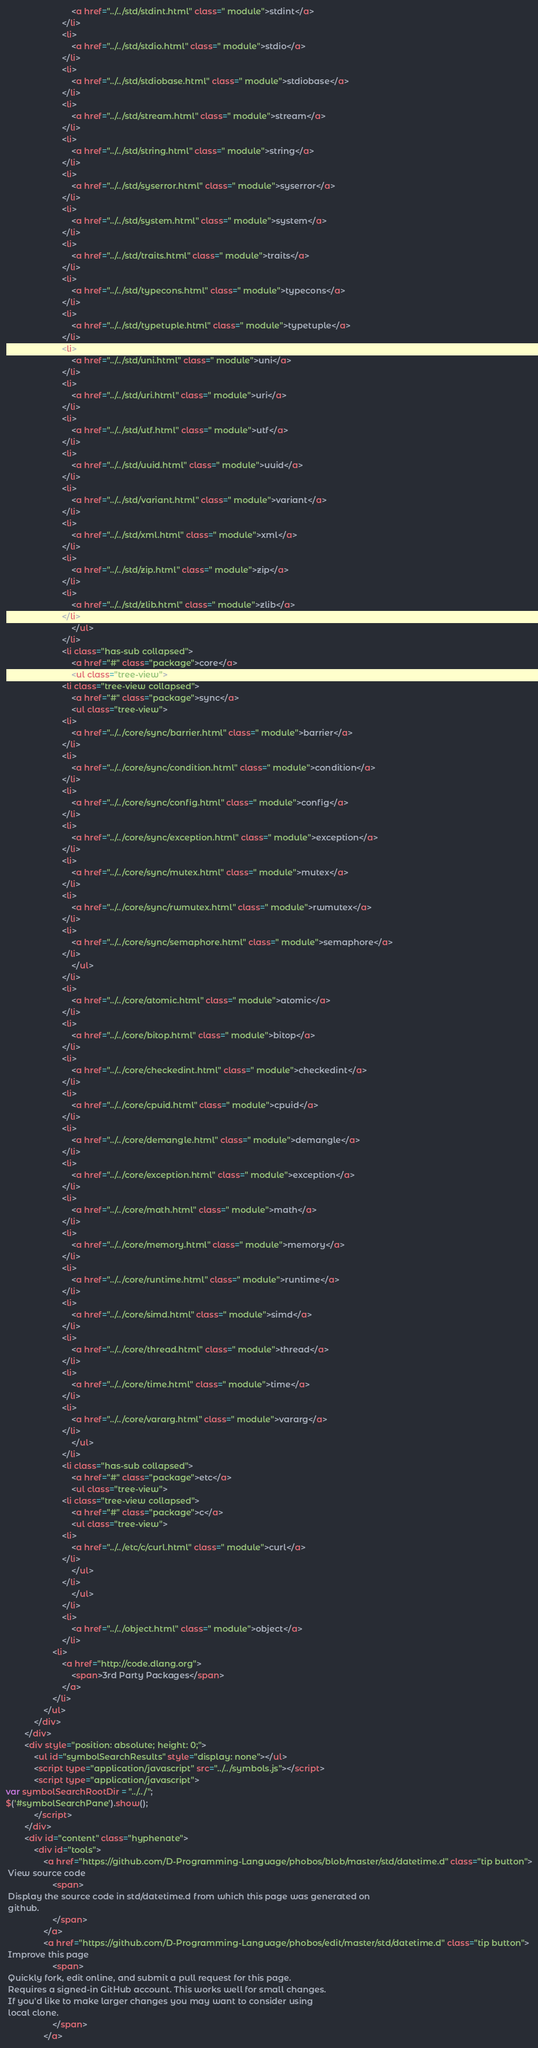Convert code to text. <code><loc_0><loc_0><loc_500><loc_500><_HTML_>							<a href="../../std/stdint.html" class=" module">stdint</a>
						</li>
						<li>
							<a href="../../std/stdio.html" class=" module">stdio</a>
						</li>
						<li>
							<a href="../../std/stdiobase.html" class=" module">stdiobase</a>
						</li>
						<li>
							<a href="../../std/stream.html" class=" module">stream</a>
						</li>
						<li>
							<a href="../../std/string.html" class=" module">string</a>
						</li>
						<li>
							<a href="../../std/syserror.html" class=" module">syserror</a>
						</li>
						<li>
							<a href="../../std/system.html" class=" module">system</a>
						</li>
						<li>
							<a href="../../std/traits.html" class=" module">traits</a>
						</li>
						<li>
							<a href="../../std/typecons.html" class=" module">typecons</a>
						</li>
						<li>
							<a href="../../std/typetuple.html" class=" module">typetuple</a>
						</li>
						<li>
							<a href="../../std/uni.html" class=" module">uni</a>
						</li>
						<li>
							<a href="../../std/uri.html" class=" module">uri</a>
						</li>
						<li>
							<a href="../../std/utf.html" class=" module">utf</a>
						</li>
						<li>
							<a href="../../std/uuid.html" class=" module">uuid</a>
						</li>
						<li>
							<a href="../../std/variant.html" class=" module">variant</a>
						</li>
						<li>
							<a href="../../std/xml.html" class=" module">xml</a>
						</li>
						<li>
							<a href="../../std/zip.html" class=" module">zip</a>
						</li>
						<li>
							<a href="../../std/zlib.html" class=" module">zlib</a>
						</li>
							</ul>
						</li>
						<li class="has-sub collapsed">
							<a href="#" class="package">core</a>
							<ul class="tree-view">
						<li class="tree-view collapsed">
							<a href="#" class="package">sync</a>
							<ul class="tree-view">
						<li>
							<a href="../../core/sync/barrier.html" class=" module">barrier</a>
						</li>
						<li>
							<a href="../../core/sync/condition.html" class=" module">condition</a>
						</li>
						<li>
							<a href="../../core/sync/config.html" class=" module">config</a>
						</li>
						<li>
							<a href="../../core/sync/exception.html" class=" module">exception</a>
						</li>
						<li>
							<a href="../../core/sync/mutex.html" class=" module">mutex</a>
						</li>
						<li>
							<a href="../../core/sync/rwmutex.html" class=" module">rwmutex</a>
						</li>
						<li>
							<a href="../../core/sync/semaphore.html" class=" module">semaphore</a>
						</li>
							</ul>
						</li>
						<li>
							<a href="../../core/atomic.html" class=" module">atomic</a>
						</li>
						<li>
							<a href="../../core/bitop.html" class=" module">bitop</a>
						</li>
						<li>
							<a href="../../core/checkedint.html" class=" module">checkedint</a>
						</li>
						<li>
							<a href="../../core/cpuid.html" class=" module">cpuid</a>
						</li>
						<li>
							<a href="../../core/demangle.html" class=" module">demangle</a>
						</li>
						<li>
							<a href="../../core/exception.html" class=" module">exception</a>
						</li>
						<li>
							<a href="../../core/math.html" class=" module">math</a>
						</li>
						<li>
							<a href="../../core/memory.html" class=" module">memory</a>
						</li>
						<li>
							<a href="../../core/runtime.html" class=" module">runtime</a>
						</li>
						<li>
							<a href="../../core/simd.html" class=" module">simd</a>
						</li>
						<li>
							<a href="../../core/thread.html" class=" module">thread</a>
						</li>
						<li>
							<a href="../../core/time.html" class=" module">time</a>
						</li>
						<li>
							<a href="../../core/vararg.html" class=" module">vararg</a>
						</li>
							</ul>
						</li>
						<li class="has-sub collapsed">
							<a href="#" class="package">etc</a>
							<ul class="tree-view">
						<li class="tree-view collapsed">
							<a href="#" class="package">c</a>
							<ul class="tree-view">
						<li>
							<a href="../../etc/c/curl.html" class=" module">curl</a>
						</li>
							</ul>
						</li>
							</ul>
						</li>
						<li>
							<a href="../../object.html" class=" module">object</a>
						</li>
					<li>
						<a href="http://code.dlang.org">
							<span>3rd Party Packages</span>
						</a>
					</li>
				</ul>
			</div>
		</div>
		<div style="position: absolute; height: 0;">
			<ul id="symbolSearchResults" style="display: none"></ul>
			<script type="application/javascript" src="../../symbols.js"></script>
			<script type="application/javascript">
var symbolSearchRootDir = "../../";
$('#symbolSearchPane').show();
			</script>
		</div>
		<div id="content" class="hyphenate">
			<div id="tools">
				<a href="https://github.com/D-Programming-Language/phobos/blob/master/std/datetime.d" class="tip button">
 View source code
					<span>
 Display the source code in std/datetime.d from which this page was generated on
 github.
					</span>
				</a>
				<a href="https://github.com/D-Programming-Language/phobos/edit/master/std/datetime.d" class="tip button">
 Improve this page
					<span>
 Quickly fork, edit online, and submit a pull request for this page.
 Requires a signed-in GitHub account. This works well for small changes.
 If you'd like to make larger changes you may want to consider using
 local clone.
					</span>
				</a></code> 